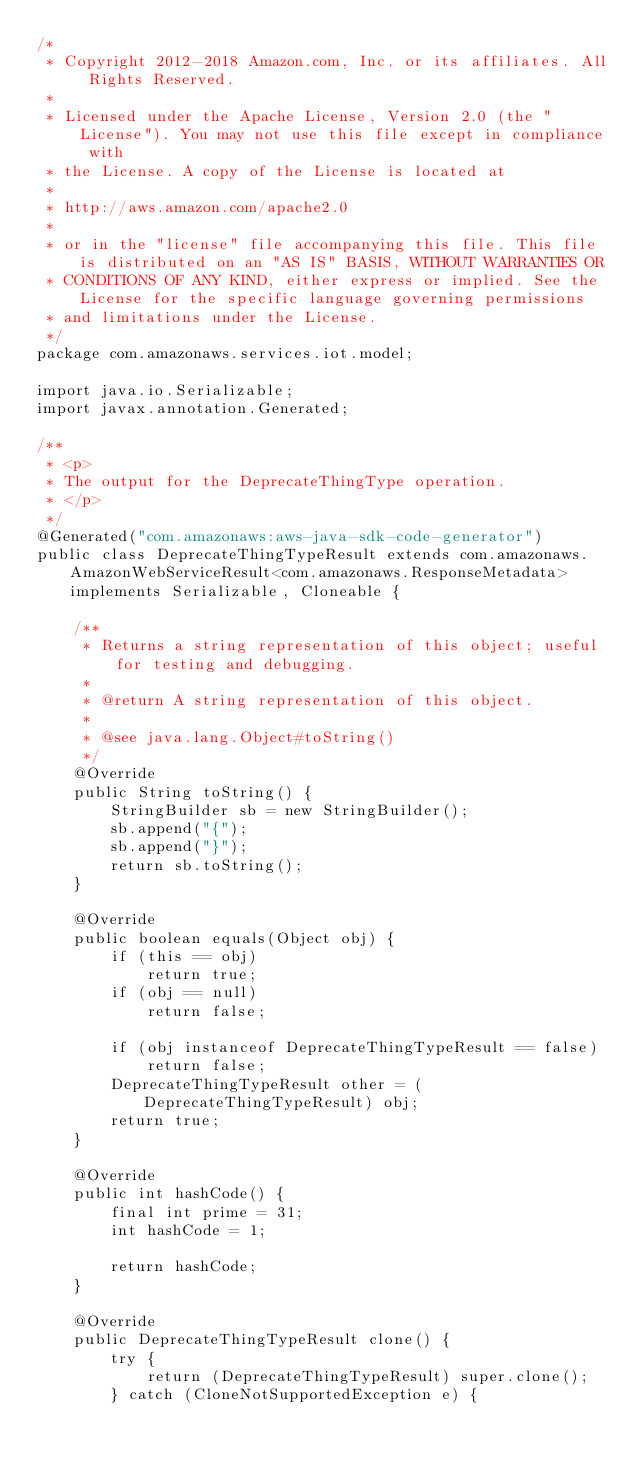Convert code to text. <code><loc_0><loc_0><loc_500><loc_500><_Java_>/*
 * Copyright 2012-2018 Amazon.com, Inc. or its affiliates. All Rights Reserved.
 * 
 * Licensed under the Apache License, Version 2.0 (the "License"). You may not use this file except in compliance with
 * the License. A copy of the License is located at
 * 
 * http://aws.amazon.com/apache2.0
 * 
 * or in the "license" file accompanying this file. This file is distributed on an "AS IS" BASIS, WITHOUT WARRANTIES OR
 * CONDITIONS OF ANY KIND, either express or implied. See the License for the specific language governing permissions
 * and limitations under the License.
 */
package com.amazonaws.services.iot.model;

import java.io.Serializable;
import javax.annotation.Generated;

/**
 * <p>
 * The output for the DeprecateThingType operation.
 * </p>
 */
@Generated("com.amazonaws:aws-java-sdk-code-generator")
public class DeprecateThingTypeResult extends com.amazonaws.AmazonWebServiceResult<com.amazonaws.ResponseMetadata> implements Serializable, Cloneable {

    /**
     * Returns a string representation of this object; useful for testing and debugging.
     *
     * @return A string representation of this object.
     *
     * @see java.lang.Object#toString()
     */
    @Override
    public String toString() {
        StringBuilder sb = new StringBuilder();
        sb.append("{");
        sb.append("}");
        return sb.toString();
    }

    @Override
    public boolean equals(Object obj) {
        if (this == obj)
            return true;
        if (obj == null)
            return false;

        if (obj instanceof DeprecateThingTypeResult == false)
            return false;
        DeprecateThingTypeResult other = (DeprecateThingTypeResult) obj;
        return true;
    }

    @Override
    public int hashCode() {
        final int prime = 31;
        int hashCode = 1;

        return hashCode;
    }

    @Override
    public DeprecateThingTypeResult clone() {
        try {
            return (DeprecateThingTypeResult) super.clone();
        } catch (CloneNotSupportedException e) {</code> 